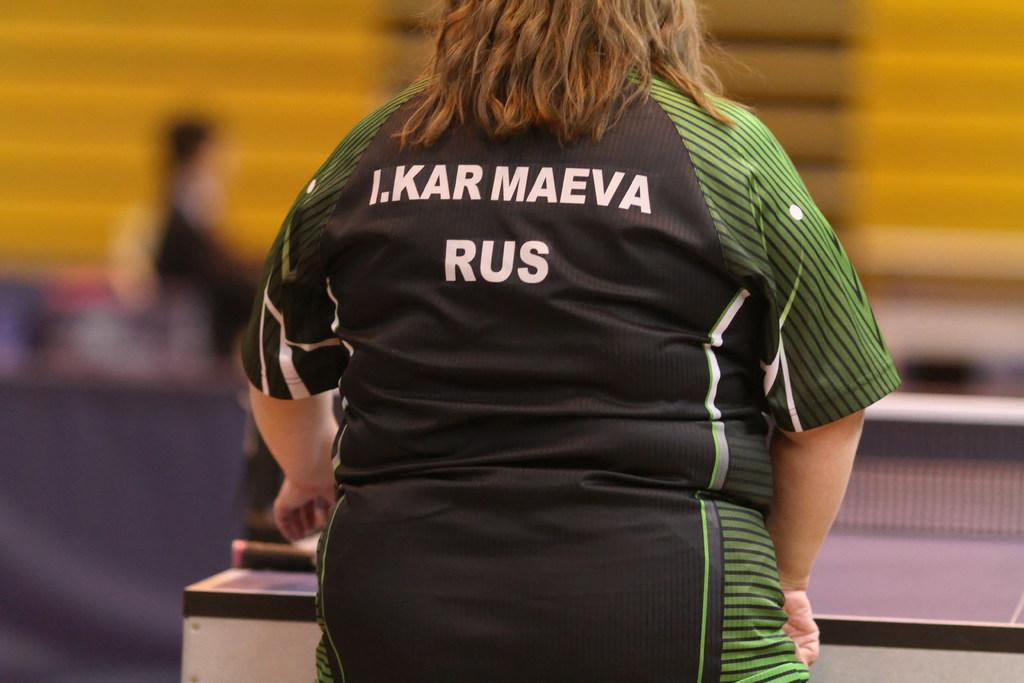<image>
Render a clear and concise summary of the photo. RUS, the country of origin of a heavyset female ping-pong player, is visible on her shirt. 